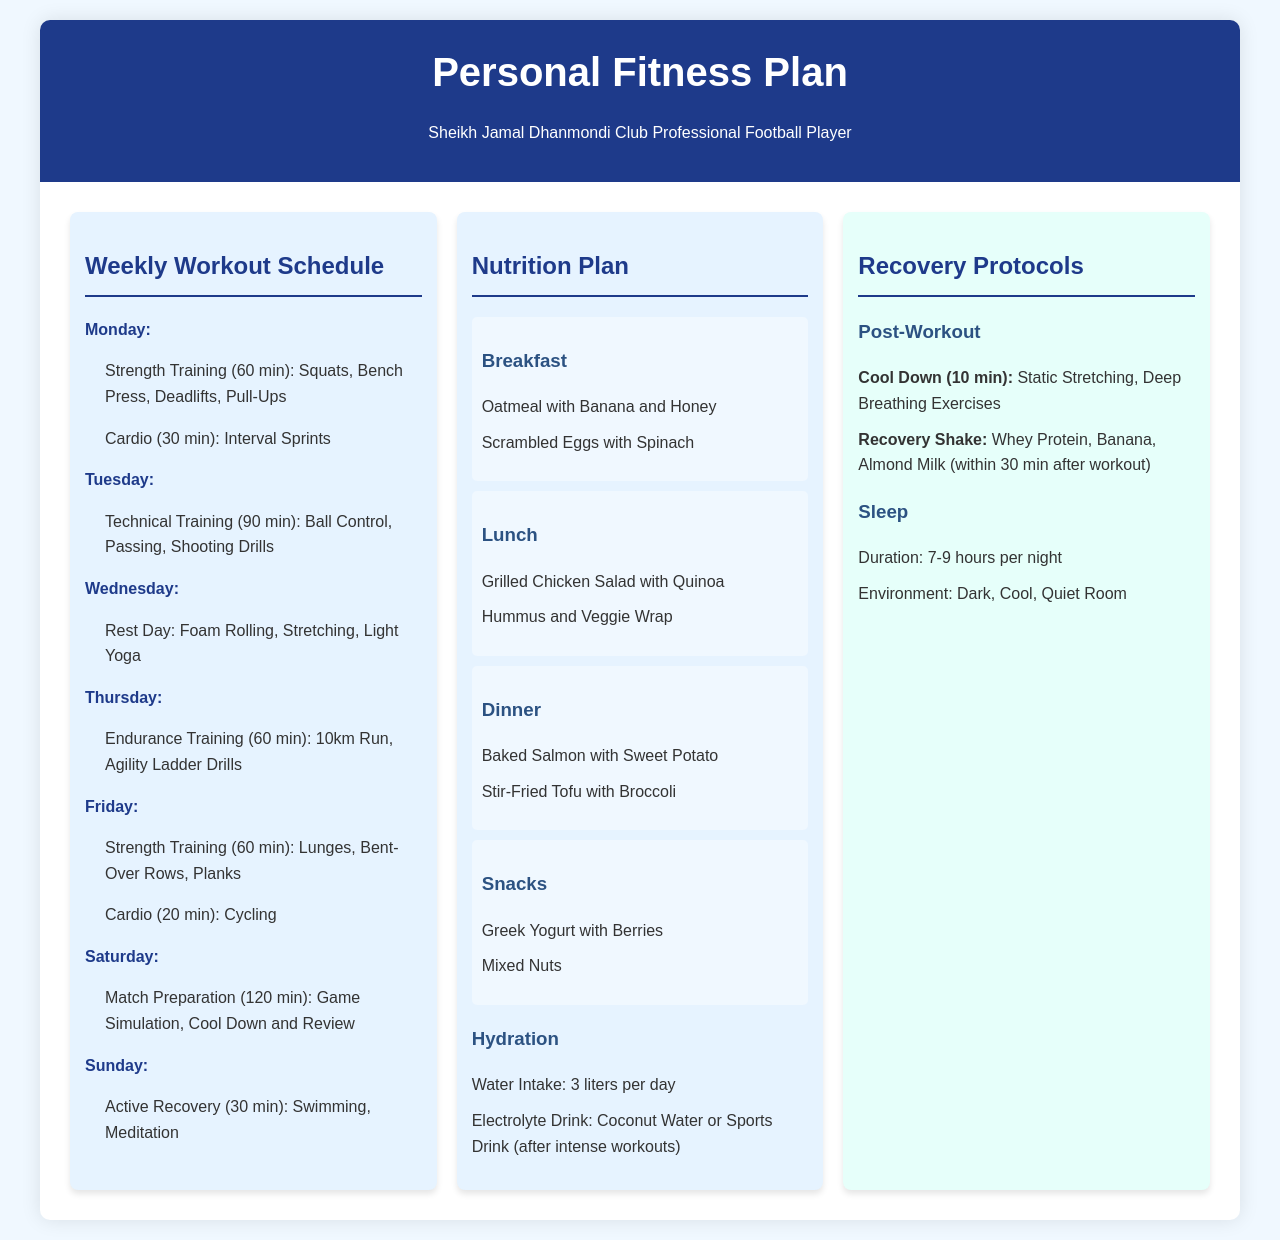What is the duration of the strength training on Monday? The strength training duration on Monday is specified in the schedule, which is 60 minutes.
Answer: 60 min What sports drink is suggested for hydration after intense workouts? The document mentions coconut water or a sports drink as the options for rehydration after intense workouts.
Answer: Coconut water or sports drink What kind of training is scheduled for Tuesday? The schedule outlines technical training for Tuesday, which includes specific drills such as ball control and passing.
Answer: Technical Training How many liters of water should be consumed daily? The hydration section indicates the recommended water intake is 3 liters per day.
Answer: 3 liters What is the primary focus of the Thursday workout? The workout on Thursday emphasizes endurance training as indicated in the document.
Answer: Endurance Training What are the active recovery activities scheduled for Sunday? The document lists swimming and meditation as the active recovery activities assigned for Sunday.
Answer: Swimming, Meditation How long should the cool down last after a workout? The cool down period specified in the recovery protocols is 10 minutes after workouts.
Answer: 10 min What is included in the breakfast meal? The breakfast section lists oatmeal with banana and honey, and scrambled eggs with spinach as included items.
Answer: Oatmeal with Banana and Honey, Scrambled Eggs with Spinach What is the total duration of match preparation on Saturday? According to the schedule, match preparation on Saturday lasts for 120 minutes.
Answer: 120 min 